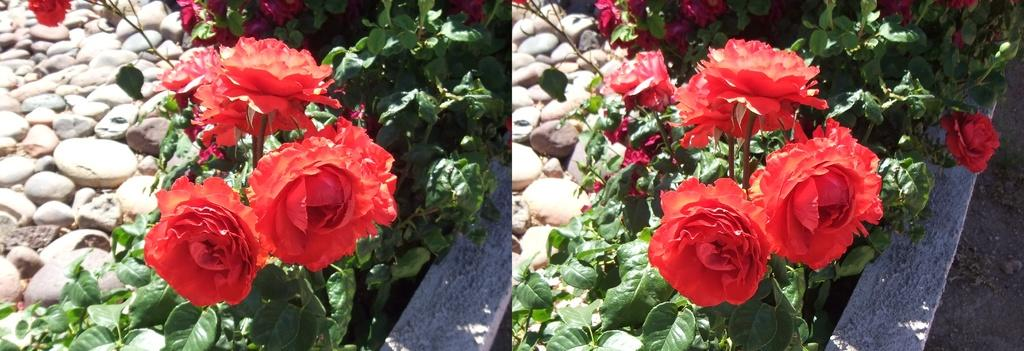How many images are present in the picture? There are two images in the picture. What is depicted in one of the images? One image contains a plant with roses. What color are the roses in the image? The roses are red in color. What is located beside the plant in the image? There are stones beside the plant. What type of furniture can be seen in the image? There is no furniture present in the image; it contains a plant with red roses and stones beside it. How many pickles are visible in the image? There are no pickles present in the image. 